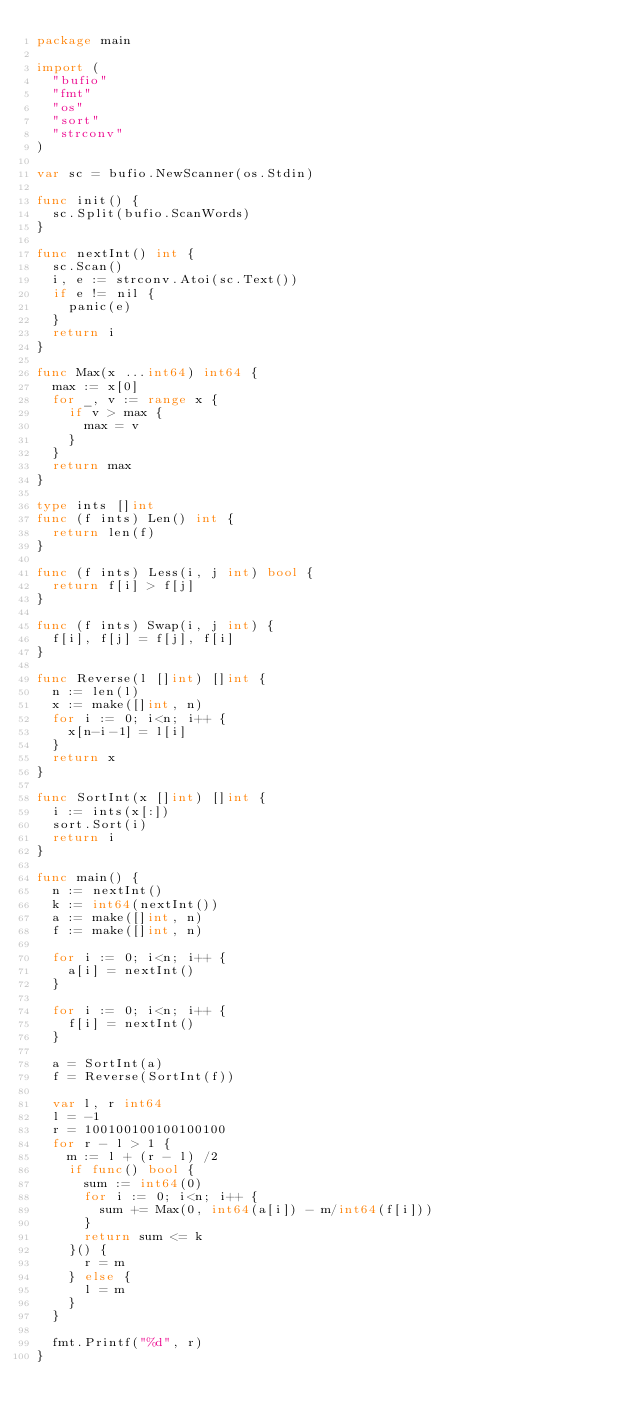Convert code to text. <code><loc_0><loc_0><loc_500><loc_500><_Go_>package main

import (
	"bufio"
	"fmt"
	"os"
	"sort"
	"strconv"
)

var sc = bufio.NewScanner(os.Stdin)

func init() {
	sc.Split(bufio.ScanWords)
}

func nextInt() int {
	sc.Scan()
	i, e := strconv.Atoi(sc.Text())
	if e != nil {
		panic(e)
	}
	return i
}

func Max(x ...int64) int64 {
	max := x[0]
	for _, v := range x {
		if v > max {
			max = v
		}
	}
	return max
}

type ints []int
func (f ints) Len() int {
	return len(f)
}

func (f ints) Less(i, j int) bool {
	return f[i] > f[j]
}

func (f ints) Swap(i, j int) {
	f[i], f[j] = f[j], f[i]
}

func Reverse(l []int) []int {
	n := len(l)
	x := make([]int, n)
	for i := 0; i<n; i++ {
		x[n-i-1] = l[i]
	}
	return x
}

func SortInt(x []int) []int {
	i := ints(x[:])
	sort.Sort(i)
	return i
}

func main() {
	n := nextInt()
	k := int64(nextInt())
	a := make([]int, n)
	f := make([]int, n)

	for i := 0; i<n; i++ {
		a[i] = nextInt()
	}

	for i := 0; i<n; i++ {
		f[i] = nextInt()
	}

	a = SortInt(a)
	f = Reverse(SortInt(f))

	var l, r int64
	l = -1
	r = 100100100100100100
	for r - l > 1 {
		m := l + (r - l) /2
		if func() bool {
			sum := int64(0)
			for i := 0; i<n; i++ {
				sum += Max(0, int64(a[i]) - m/int64(f[i]))
			}
			return sum <= k
		}() {
			r = m
		} else {
			l = m
		}
	}

	fmt.Printf("%d", r)
}
</code> 